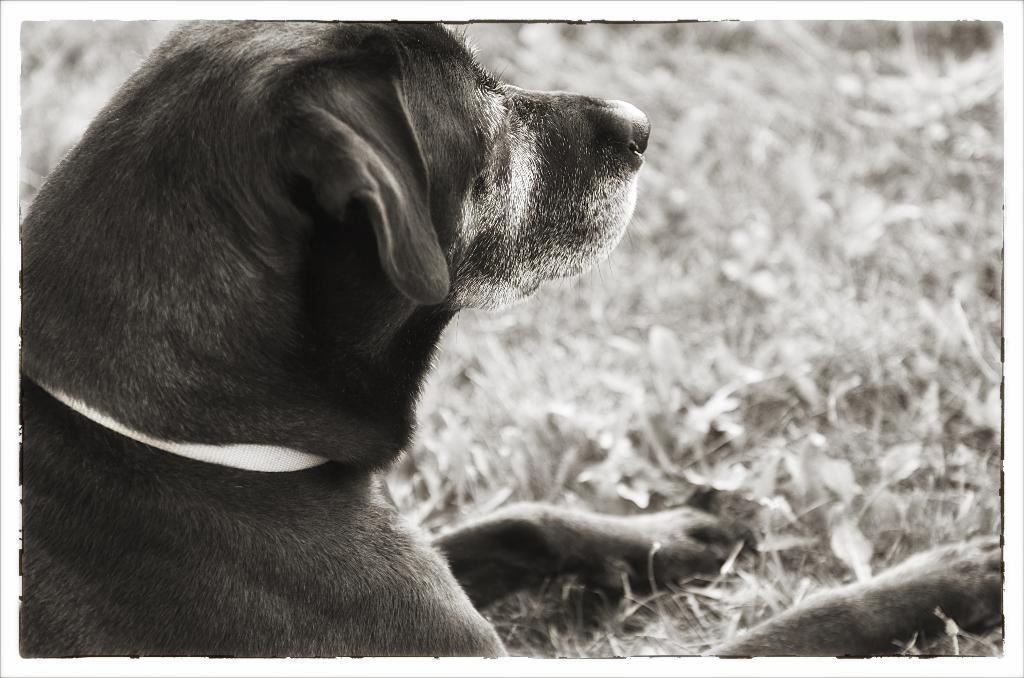Please provide a concise description of this image. In the picture there is a dog. On the right there is grass and leaves. The background is blurred. 